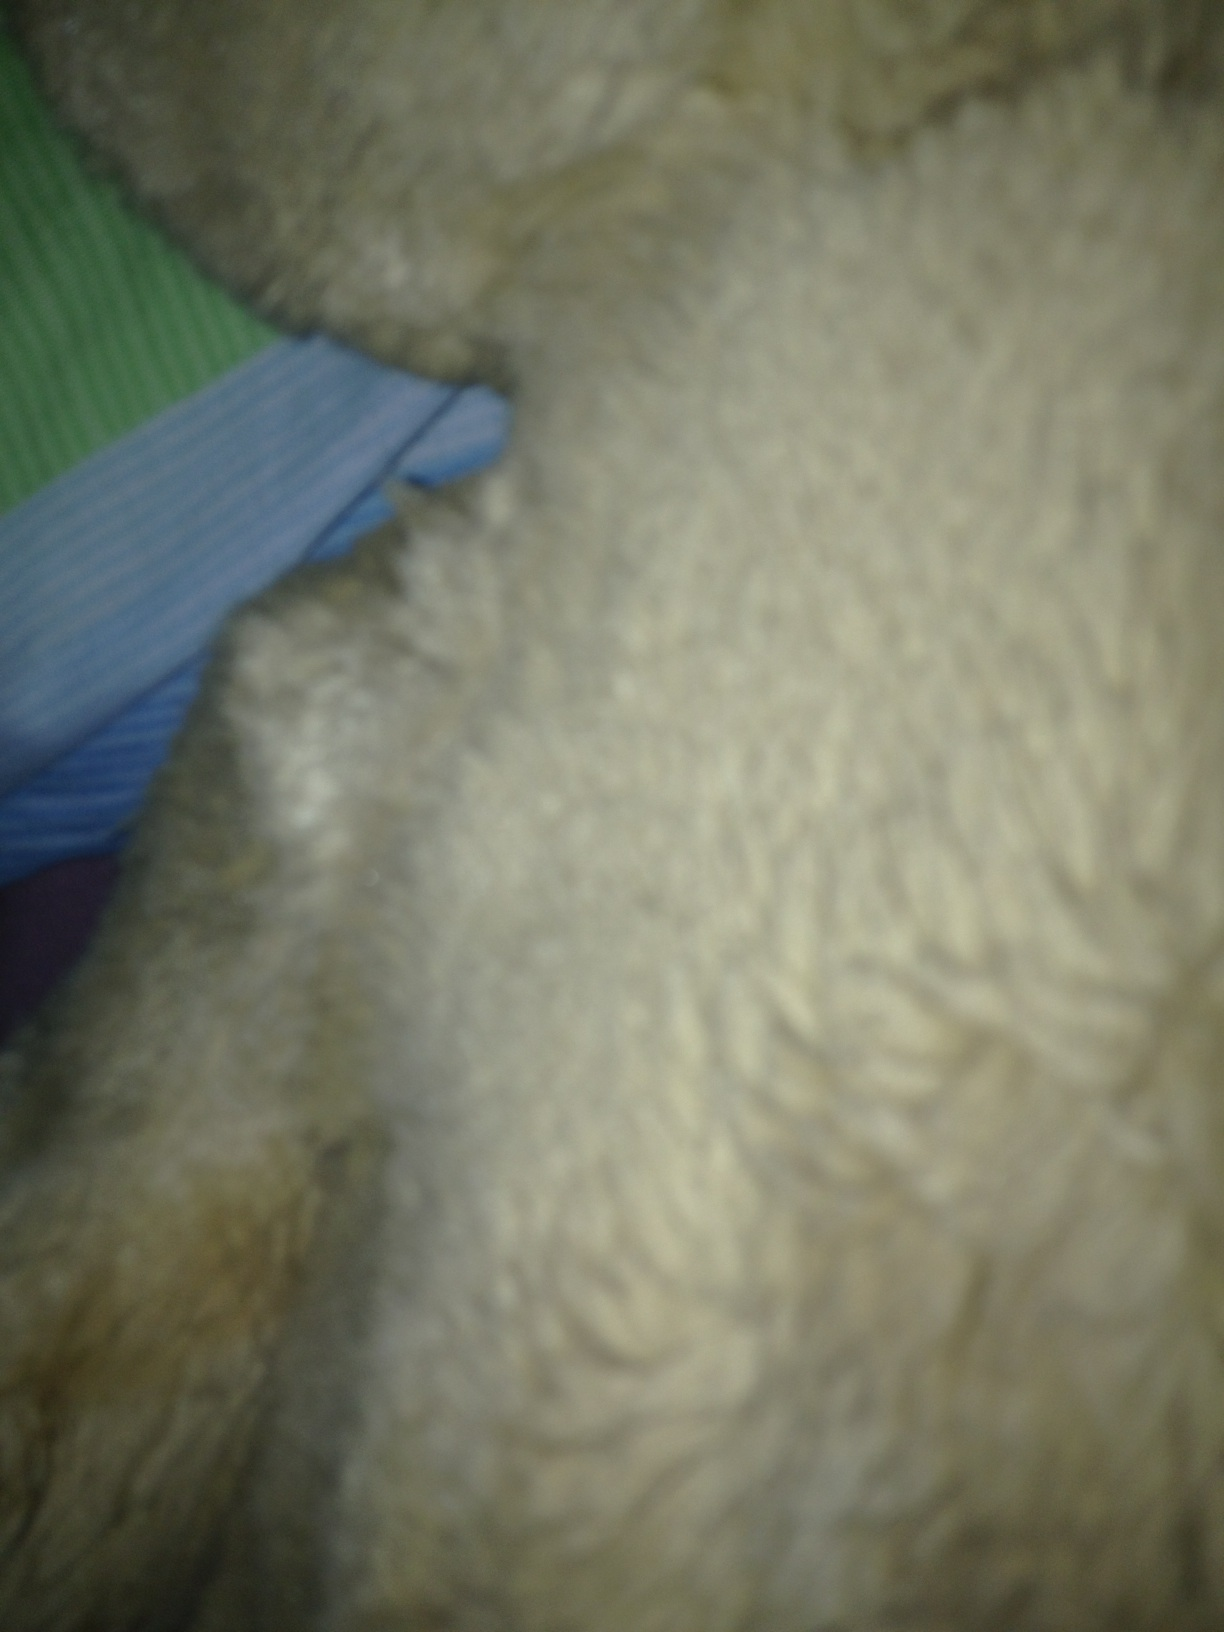What is this? This image appears to be a close-up of a fuzzy or furry texture, possibly part of a stuffed animal or a fluffy fabric. 